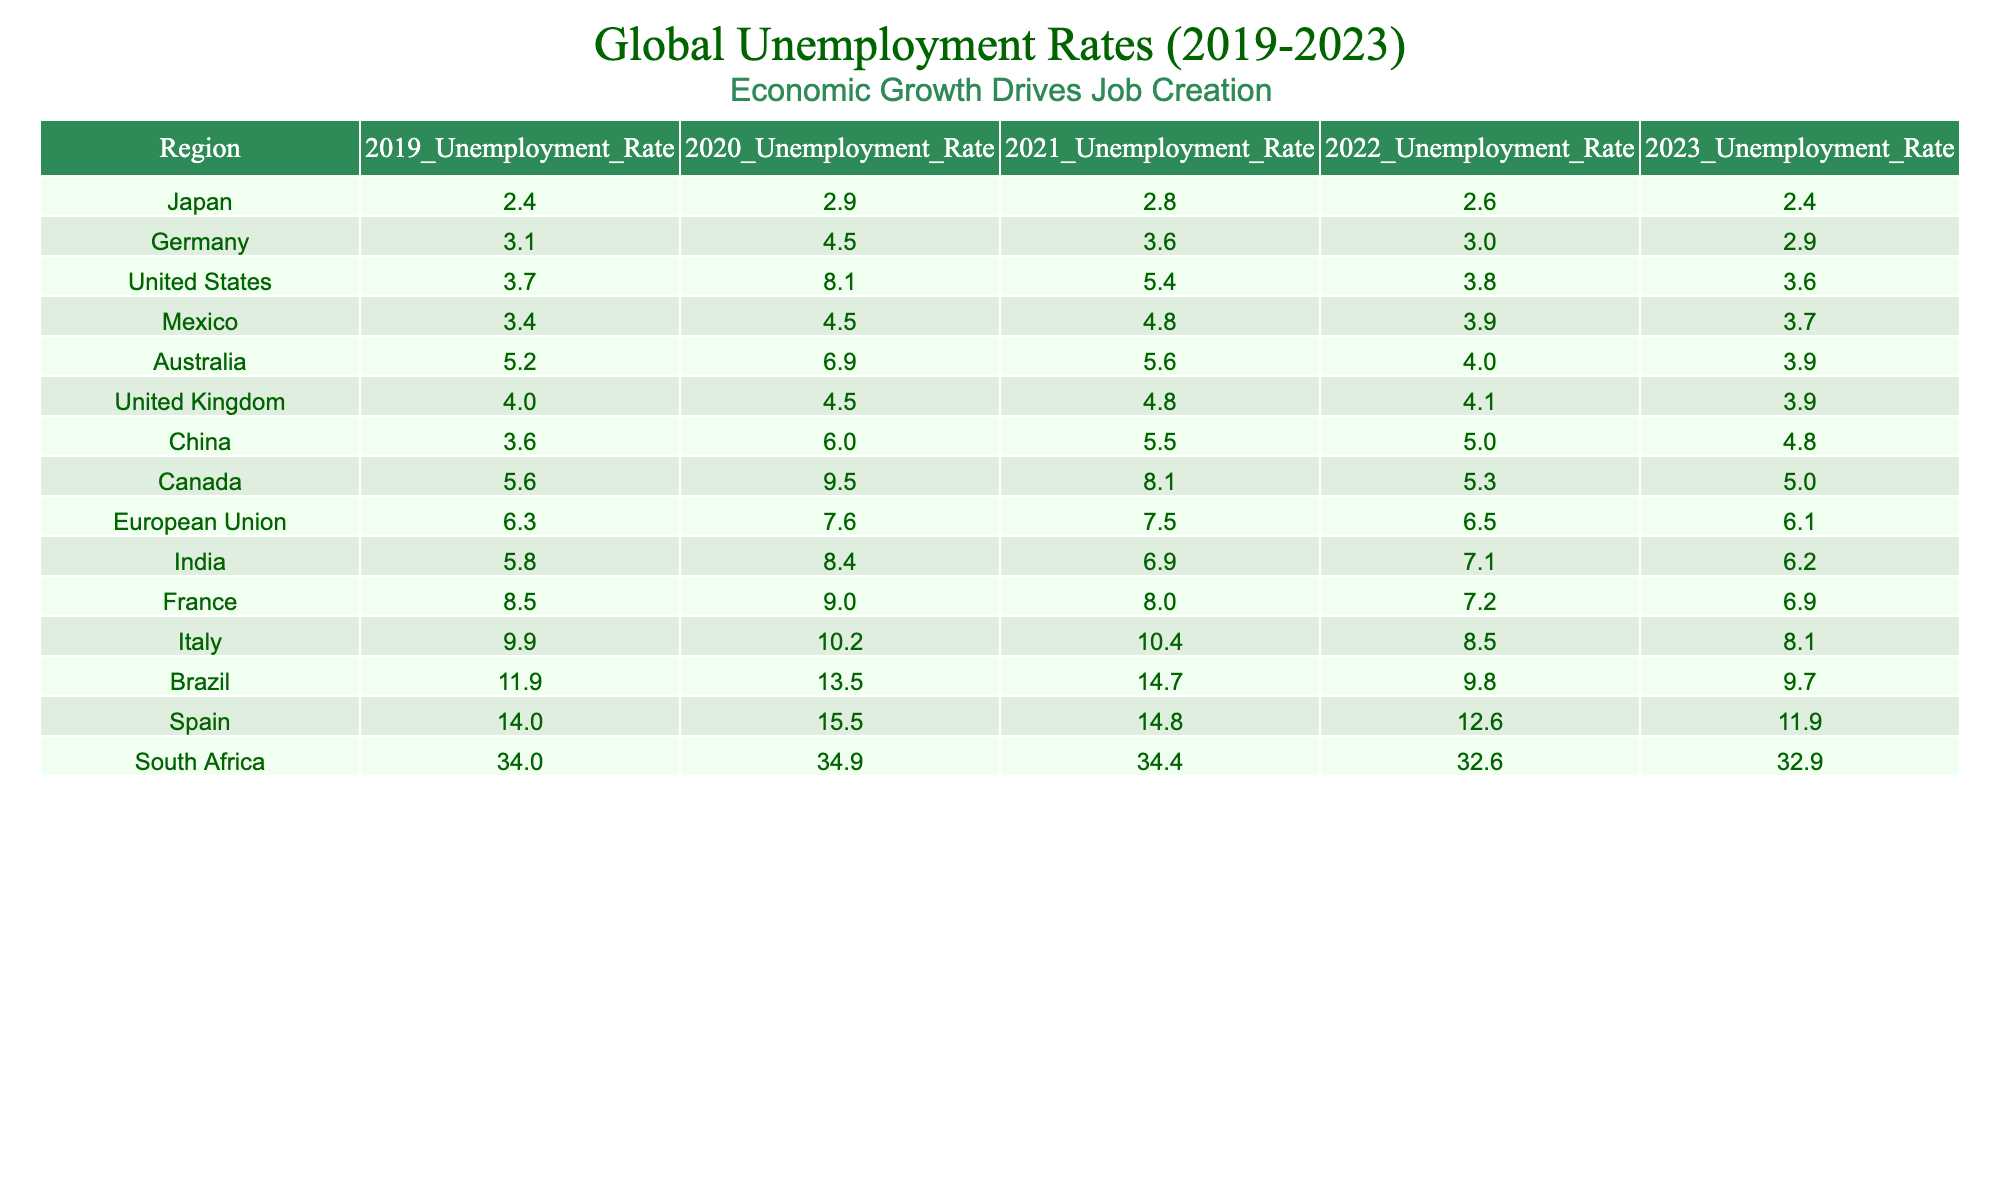What was the unemployment rate in the United States in 2020? Referring to the table, the unemployment rate for the United States in 2020 is directly listed as 8.1%.
Answer: 8.1% Which region had the highest unemployment rate in 2019? By checking the table, South Africa has the highest unemployment rate in 2019 at 34.0%.
Answer: South Africa What is the difference in unemployment rates for Canada from 2019 to 2023? The unemployment rate in Canada is 5.6% in 2019 and 5.0% in 2023. The difference is calculated as 5.6% - 5.0% = 0.6%.
Answer: 0.6% What was the average unemployment rate for India over the last five years? To find the average, sum the rates for 2019 (5.8%), 2020 (8.4%), 2021 (6.9%), 2022 (7.1%), and 2023 (6.2%), which gives 34.4%. Then, divide by 5: 34.4% / 5 = 6.88%.
Answer: 6.88% Did the unemployment rate in Germany decrease from 2019 to 2023? Comparing the unemployment rates, Germany's rate was 3.1% in 2019 and decreased to 2.9% in 2023, indicating a decrease.
Answer: Yes Which region has shown the most significant decrease in unemployment rates from 2019 to 2023? By comparing the rates, Brazil has decreased from 11.9% in 2019 to 9.7% in 2023, a difference of 2.2%. In contrast, countries like South Africa had a smaller decrease.
Answer: Brazil (2.2% decrease) What has been the trend of unemployment rates in Australia over the last five years? The rates for Australia are 5.2% (2019), 6.9% (2020), 5.6% (2021), 4.0% (2022), and 3.9% (2023). The trend shows an initial increase, followed by a decrease over the next three years.
Answer: Decrease after initial increase Which two regions had the same unemployment rate in 2022? The table shows that France and Australia both had an unemployment rate of 4.0% in 2022.
Answer: France and Australia Is it true that the unemployment rate in the European Union was lower than in the United States every year from 2019 to 2023? Checking the rates, in 2019, the EU's rate was 6.3%, while the US rate was 3.7%. Therefore, the statement is false for 2019.
Answer: No What is the median unemployment rate for all regions in 2023? To find the median for 2023 rates: the rates are 2.4%, 3.6%, 3.9%, 3.9%, 4.8%, 5.0%, 6.1%, 6.2%, 8.1%, 9.7%, 11.9%, 32.9%. Sorting them gives 2.4%, 3.6%, 3.9%, 3.9%, 4.8%, 5.0%, 6.1%, 6.2%, 8.1%, 9.7%, 11.9%, 32.9%. The median (middle value) is the average of the 6th and 7th values: (5.0% + 6.1%) / 2 = 5.55%.
Answer: 5.55% 